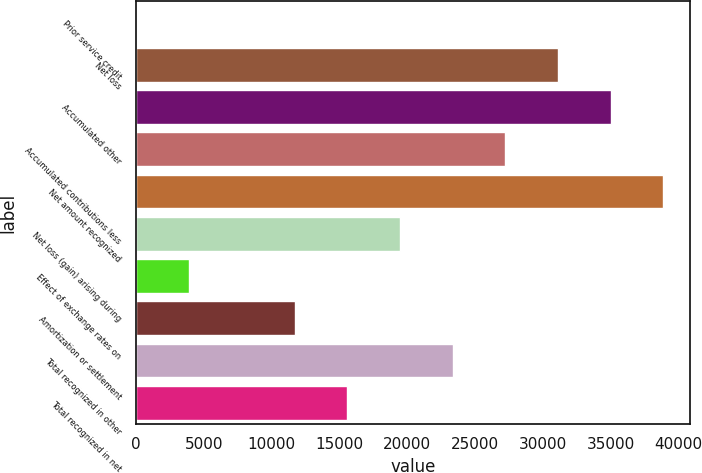Convert chart to OTSL. <chart><loc_0><loc_0><loc_500><loc_500><bar_chart><fcel>Prior service credit<fcel>Net loss<fcel>Accumulated other<fcel>Accumulated contributions less<fcel>Net amount recognized<fcel>Net loss (gain) arising during<fcel>Effect of exchange rates on<fcel>Amortization or settlement<fcel>Total recognized in other<fcel>Total recognized in net<nl><fcel>44<fcel>31115.2<fcel>34999.1<fcel>27231.3<fcel>38883<fcel>19463.5<fcel>3927.9<fcel>11695.7<fcel>23347.4<fcel>15579.6<nl></chart> 